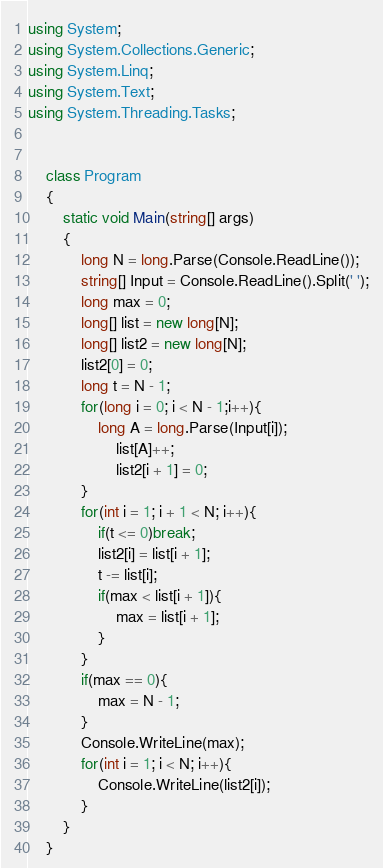Convert code to text. <code><loc_0><loc_0><loc_500><loc_500><_C#_>using System;
using System.Collections.Generic;
using System.Linq;
using System.Text;
using System.Threading.Tasks;


    class Program
    {
        static void Main(string[] args)
        {
            long N = long.Parse(Console.ReadLine());
            string[] Input = Console.ReadLine().Split(' ');
            long max = 0;
            long[] list = new long[N];
            long[] list2 = new long[N];
            list2[0] = 0;
            long t = N - 1;
            for(long i = 0; i < N - 1;i++){
                long A = long.Parse(Input[i]);
                    list[A]++;
                    list2[i + 1] = 0;
            }
            for(int i = 1; i + 1 < N; i++){
                if(t <= 0)break;
                list2[i] = list[i + 1];
                t -= list[i];
                if(max < list[i + 1]){
                    max = list[i + 1];
                }
            }
            if(max == 0){
                max = N - 1;
            }
            Console.WriteLine(max);
            for(int i = 1; i < N; i++){
                Console.WriteLine(list2[i]);
            }
        }
    }</code> 